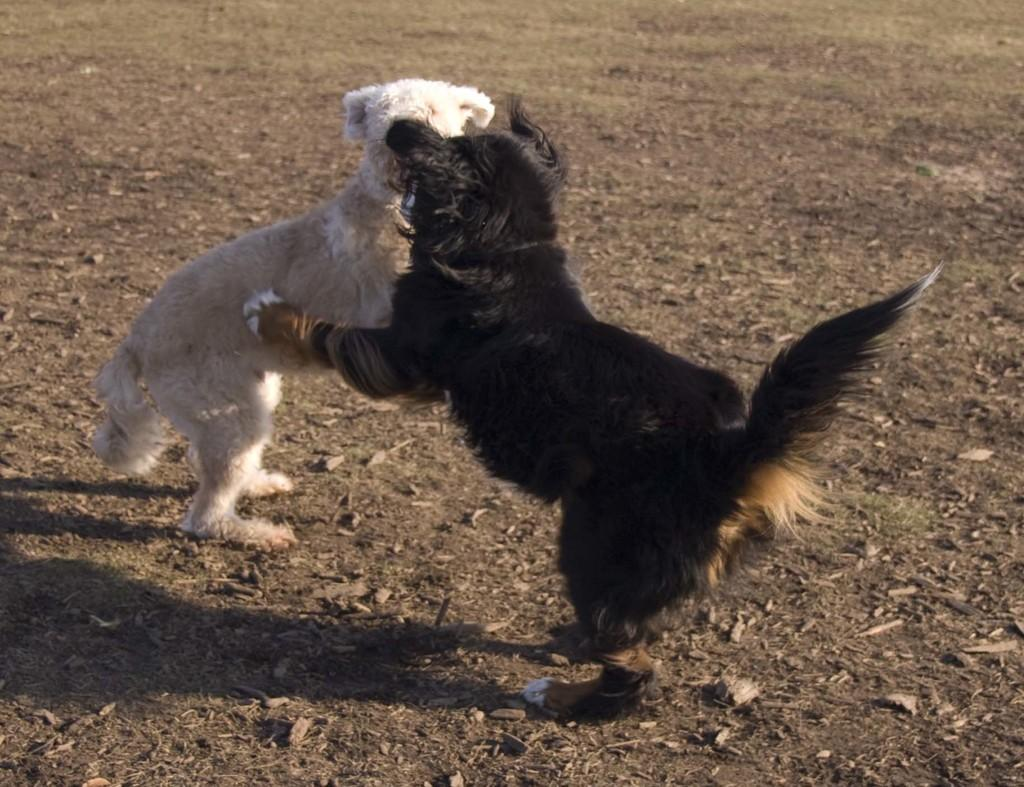What is the main setting of the image? There is an open ground in the image. What animals can be seen on the open ground? There are two dogs on the open ground. Can you describe the color of each dog? One dog has a white color, and the other dog has a black color. What type of committee is meeting in the image? There is no committee meeting in the image; it features an open ground with two dogs. What type of flesh can be seen on the dogs in the image? There is no flesh visible on the dogs in the image; they are fully covered with fur. 